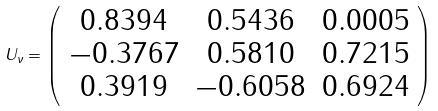<formula> <loc_0><loc_0><loc_500><loc_500>U _ { \nu } = \left ( \begin{array} { c c c } 0 . 8 3 9 4 & 0 . 5 4 3 6 & 0 . 0 0 0 5 \\ - 0 . 3 7 6 7 & 0 . 5 8 1 0 & 0 . 7 2 1 5 \\ 0 . 3 9 1 9 & - 0 . 6 0 5 8 & 0 . 6 9 2 4 \end{array} \right )</formula> 